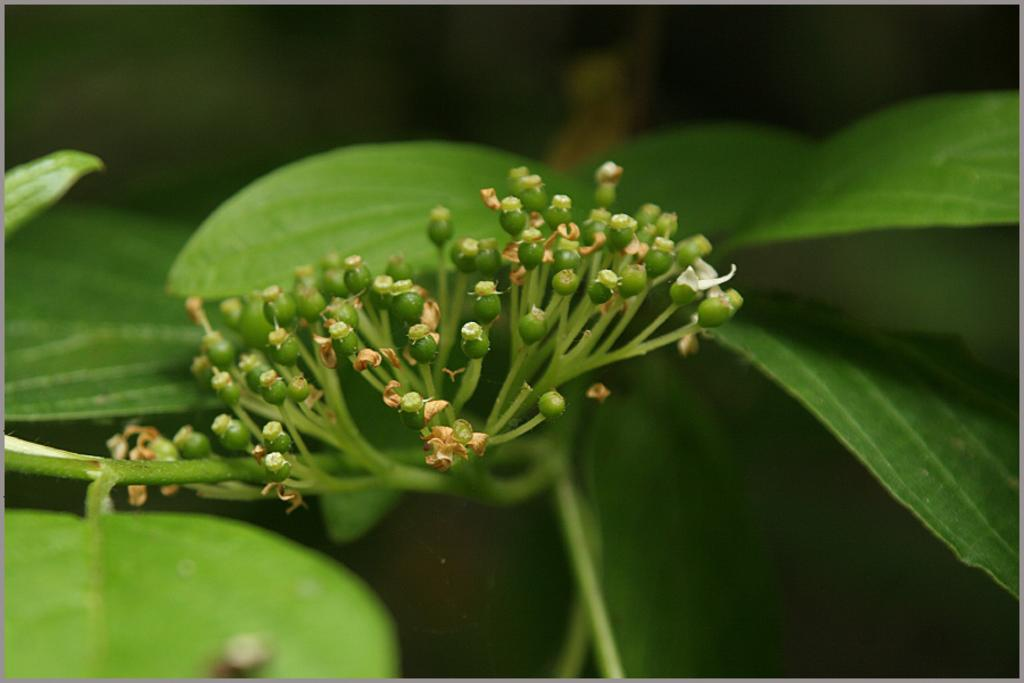What type of plant material is visible in the image? There are green leaves, buds, and stems in the image. Can you describe the stage of growth for the plants in the image? The presence of buds suggests that the plants are in the early stages of growth. What is the appearance of the background in the image? The background of the image is blurred. What type of bread can be seen in the image? There is no bread present in the image; it features plant material with green leaves, buds, and stems. Can you tell me which animals are wearing skirts in the image? There are no animals or skirts present in the image. 